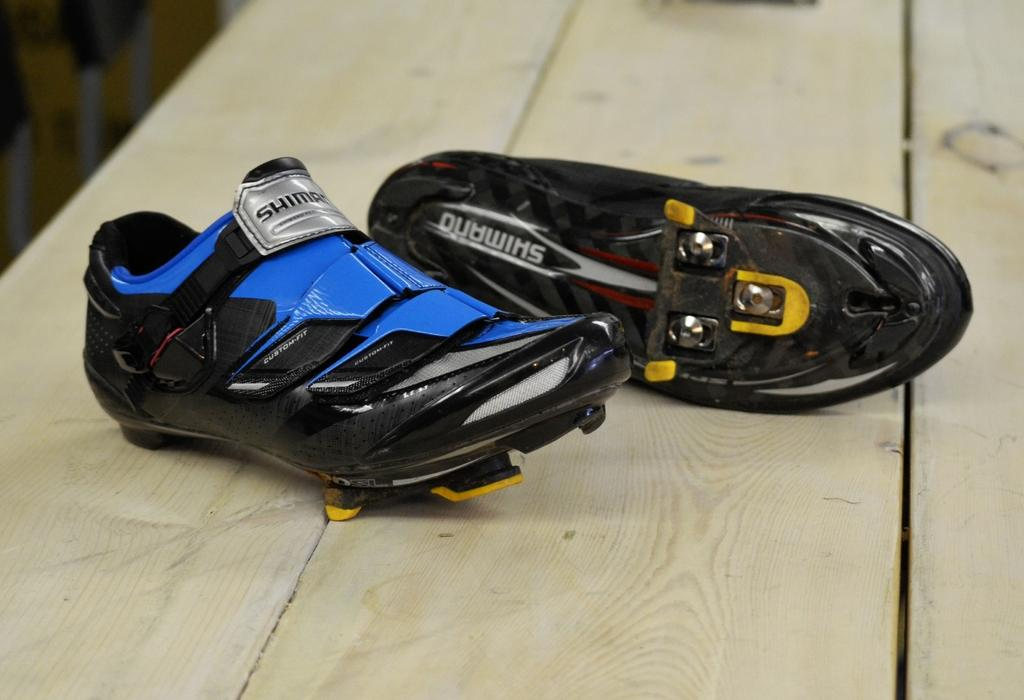What objects are in the image? There are shoes in the image. What is the shoes placed on? The shoes are placed on a wooden surface. Is there a bucket with a hole in it that has received approval in the image? There is no bucket, hole, or approval mentioned or visible in the image. 